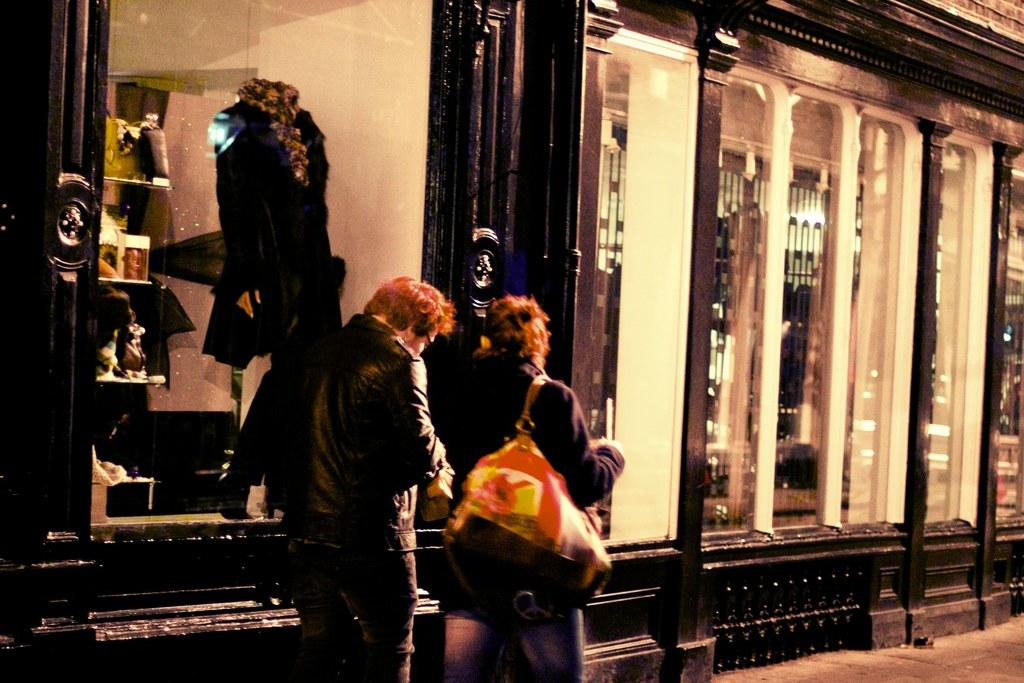What are the people in the image doing? The people in the image are walking. On what surface are the people walking? The people are walking on a pavement. What can be seen in the background of the image? There is a building in the background of the image. How many birds are in the flock flying over the people in the image? There are no birds or flock visible in the image; it only shows people walking on a pavement with a building in the background. 